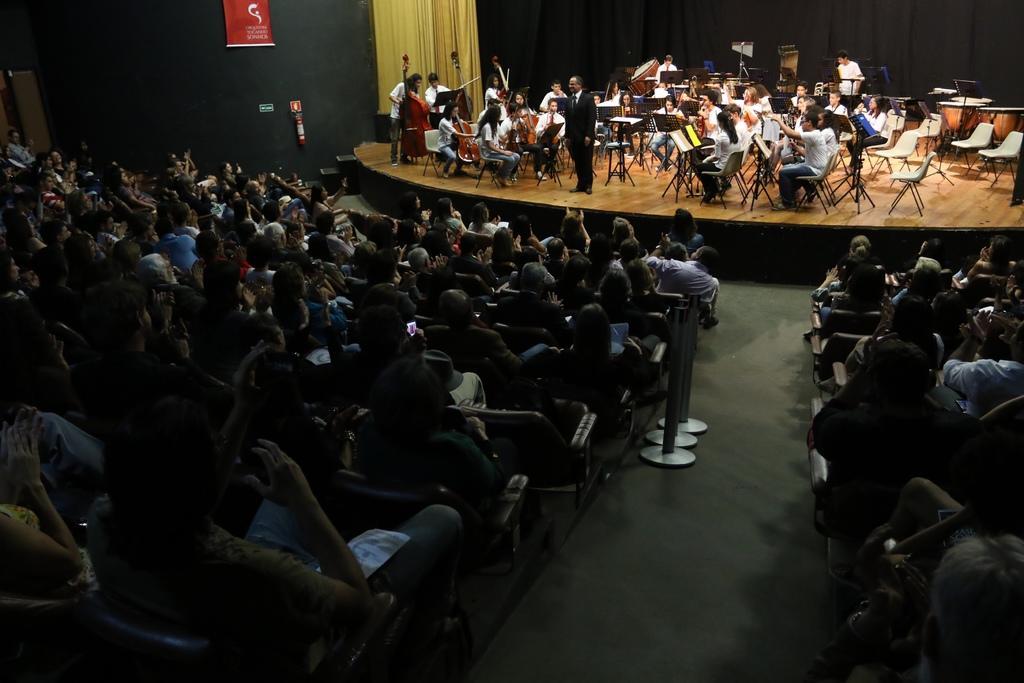Please provide a concise description of this image. At the bottom of the image there are many people sitting on the chairs. And also there are poles. In front of those people on the stage there are many people sitting on the stage and they are playing musical instruments. In front of them there are music notes stands. There is a man standing on the stage with a black jacket. In the background there are curtains. And on the wall there is a poster with text on it and there are some other things on the wall. 